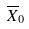<formula> <loc_0><loc_0><loc_500><loc_500>\overline { X } _ { 0 }</formula> 